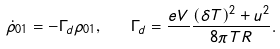<formula> <loc_0><loc_0><loc_500><loc_500>\dot { \rho } _ { 0 1 } = - \Gamma _ { d } \rho _ { 0 1 } , \quad \Gamma _ { d } = \frac { e V } { } \frac { ( \delta T ) ^ { 2 } + u ^ { 2 } } { 8 \pi T R } .</formula> 